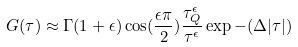Convert formula to latex. <formula><loc_0><loc_0><loc_500><loc_500>G ( \tau ) \approx \Gamma ( 1 + \epsilon ) \cos ( \frac { \epsilon \pi } { 2 } ) \frac { \tau _ { Q } ^ { \epsilon } } { \tau ^ { \epsilon } } \exp - ( \Delta | \tau | )</formula> 